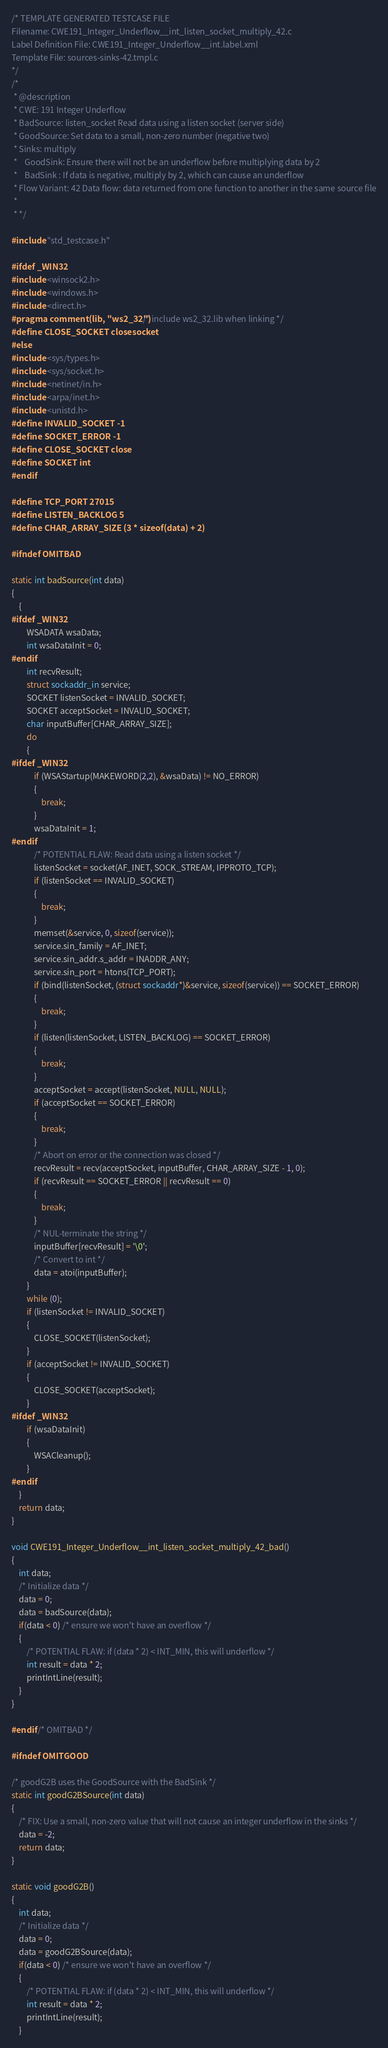<code> <loc_0><loc_0><loc_500><loc_500><_C_>/* TEMPLATE GENERATED TESTCASE FILE
Filename: CWE191_Integer_Underflow__int_listen_socket_multiply_42.c
Label Definition File: CWE191_Integer_Underflow__int.label.xml
Template File: sources-sinks-42.tmpl.c
*/
/*
 * @description
 * CWE: 191 Integer Underflow
 * BadSource: listen_socket Read data using a listen socket (server side)
 * GoodSource: Set data to a small, non-zero number (negative two)
 * Sinks: multiply
 *    GoodSink: Ensure there will not be an underflow before multiplying data by 2
 *    BadSink : If data is negative, multiply by 2, which can cause an underflow
 * Flow Variant: 42 Data flow: data returned from one function to another in the same source file
 *
 * */

#include "std_testcase.h"

#ifdef _WIN32
#include <winsock2.h>
#include <windows.h>
#include <direct.h>
#pragma comment(lib, "ws2_32") /* include ws2_32.lib when linking */
#define CLOSE_SOCKET closesocket
#else
#include <sys/types.h>
#include <sys/socket.h>
#include <netinet/in.h>
#include <arpa/inet.h>
#include <unistd.h>
#define INVALID_SOCKET -1
#define SOCKET_ERROR -1
#define CLOSE_SOCKET close
#define SOCKET int
#endif

#define TCP_PORT 27015
#define LISTEN_BACKLOG 5
#define CHAR_ARRAY_SIZE (3 * sizeof(data) + 2)

#ifndef OMITBAD

static int badSource(int data)
{
    {
#ifdef _WIN32
        WSADATA wsaData;
        int wsaDataInit = 0;
#endif
        int recvResult;
        struct sockaddr_in service;
        SOCKET listenSocket = INVALID_SOCKET;
        SOCKET acceptSocket = INVALID_SOCKET;
        char inputBuffer[CHAR_ARRAY_SIZE];
        do
        {
#ifdef _WIN32
            if (WSAStartup(MAKEWORD(2,2), &wsaData) != NO_ERROR)
            {
                break;
            }
            wsaDataInit = 1;
#endif
            /* POTENTIAL FLAW: Read data using a listen socket */
            listenSocket = socket(AF_INET, SOCK_STREAM, IPPROTO_TCP);
            if (listenSocket == INVALID_SOCKET)
            {
                break;
            }
            memset(&service, 0, sizeof(service));
            service.sin_family = AF_INET;
            service.sin_addr.s_addr = INADDR_ANY;
            service.sin_port = htons(TCP_PORT);
            if (bind(listenSocket, (struct sockaddr*)&service, sizeof(service)) == SOCKET_ERROR)
            {
                break;
            }
            if (listen(listenSocket, LISTEN_BACKLOG) == SOCKET_ERROR)
            {
                break;
            }
            acceptSocket = accept(listenSocket, NULL, NULL);
            if (acceptSocket == SOCKET_ERROR)
            {
                break;
            }
            /* Abort on error or the connection was closed */
            recvResult = recv(acceptSocket, inputBuffer, CHAR_ARRAY_SIZE - 1, 0);
            if (recvResult == SOCKET_ERROR || recvResult == 0)
            {
                break;
            }
            /* NUL-terminate the string */
            inputBuffer[recvResult] = '\0';
            /* Convert to int */
            data = atoi(inputBuffer);
        }
        while (0);
        if (listenSocket != INVALID_SOCKET)
        {
            CLOSE_SOCKET(listenSocket);
        }
        if (acceptSocket != INVALID_SOCKET)
        {
            CLOSE_SOCKET(acceptSocket);
        }
#ifdef _WIN32
        if (wsaDataInit)
        {
            WSACleanup();
        }
#endif
    }
    return data;
}

void CWE191_Integer_Underflow__int_listen_socket_multiply_42_bad()
{
    int data;
    /* Initialize data */
    data = 0;
    data = badSource(data);
    if(data < 0) /* ensure we won't have an overflow */
    {
        /* POTENTIAL FLAW: if (data * 2) < INT_MIN, this will underflow */
        int result = data * 2;
        printIntLine(result);
    }
}

#endif /* OMITBAD */

#ifndef OMITGOOD

/* goodG2B uses the GoodSource with the BadSink */
static int goodG2BSource(int data)
{
    /* FIX: Use a small, non-zero value that will not cause an integer underflow in the sinks */
    data = -2;
    return data;
}

static void goodG2B()
{
    int data;
    /* Initialize data */
    data = 0;
    data = goodG2BSource(data);
    if(data < 0) /* ensure we won't have an overflow */
    {
        /* POTENTIAL FLAW: if (data * 2) < INT_MIN, this will underflow */
        int result = data * 2;
        printIntLine(result);
    }</code> 